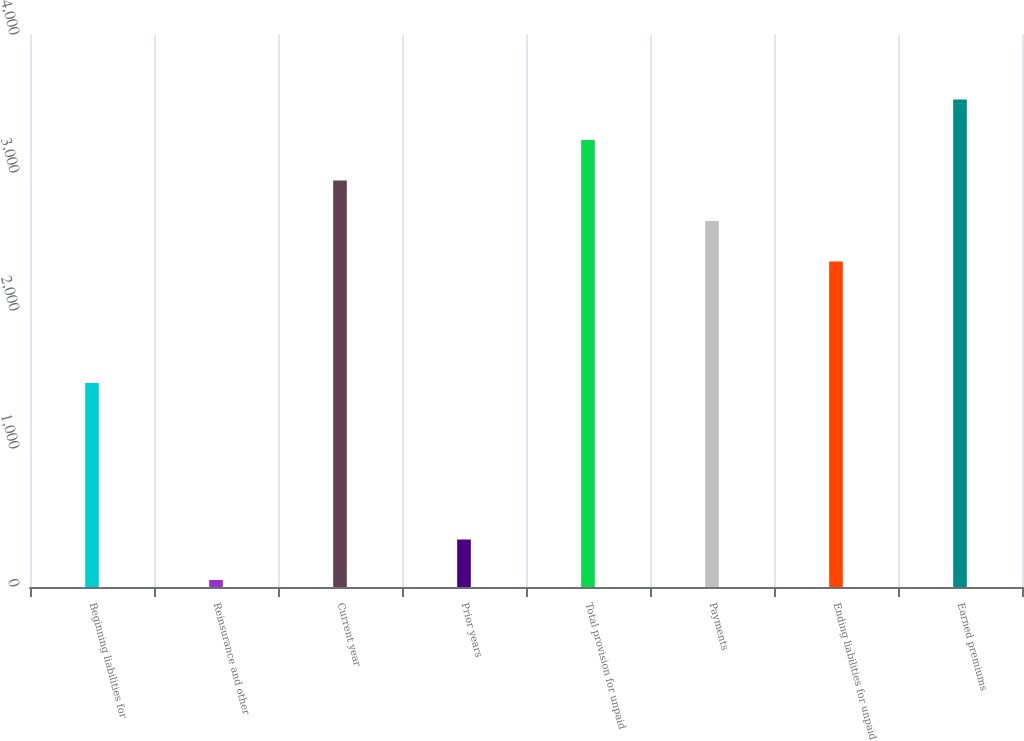Convert chart to OTSL. <chart><loc_0><loc_0><loc_500><loc_500><bar_chart><fcel>Beginning liabilities for<fcel>Reinsurance and other<fcel>Current year<fcel>Prior years<fcel>Total provision for unpaid<fcel>Payments<fcel>Ending liabilities for unpaid<fcel>Earned premiums<nl><fcel>1479<fcel>51<fcel>2945.5<fcel>344.3<fcel>3238.8<fcel>2652.2<fcel>2358.9<fcel>3532.1<nl></chart> 